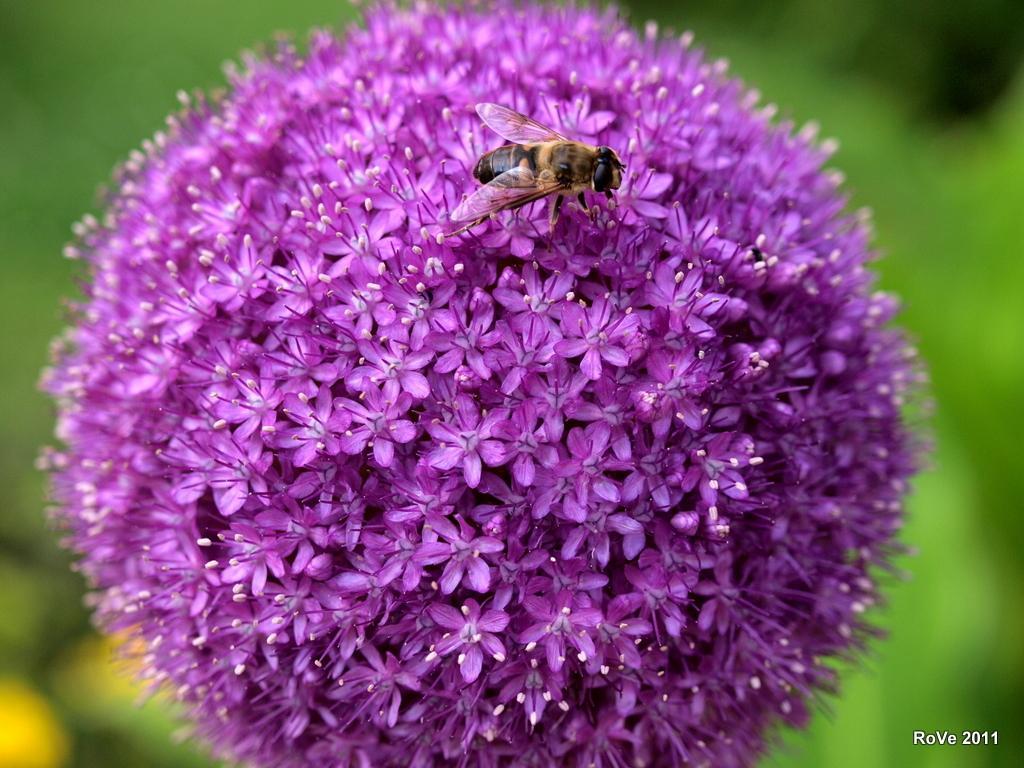How would you summarize this image in a sentence or two? In this image there is a bee on the flower. 